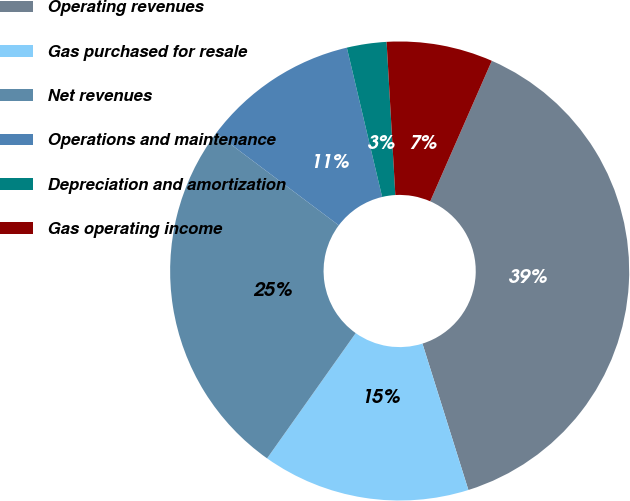Convert chart. <chart><loc_0><loc_0><loc_500><loc_500><pie_chart><fcel>Operating revenues<fcel>Gas purchased for resale<fcel>Net revenues<fcel>Operations and maintenance<fcel>Depreciation and amortization<fcel>Gas operating income<nl><fcel>38.58%<fcel>14.64%<fcel>25.44%<fcel>11.06%<fcel>2.79%<fcel>7.48%<nl></chart> 